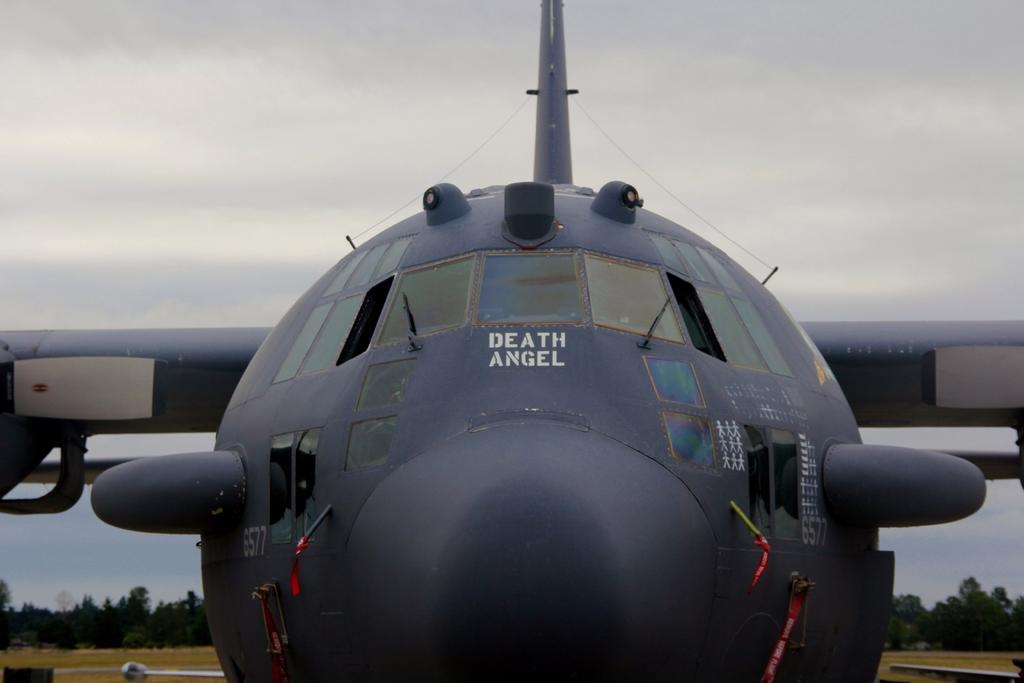What kind of angel is this?
Give a very brief answer. Death. What is the name of the plane?
Give a very brief answer. Death angel. 